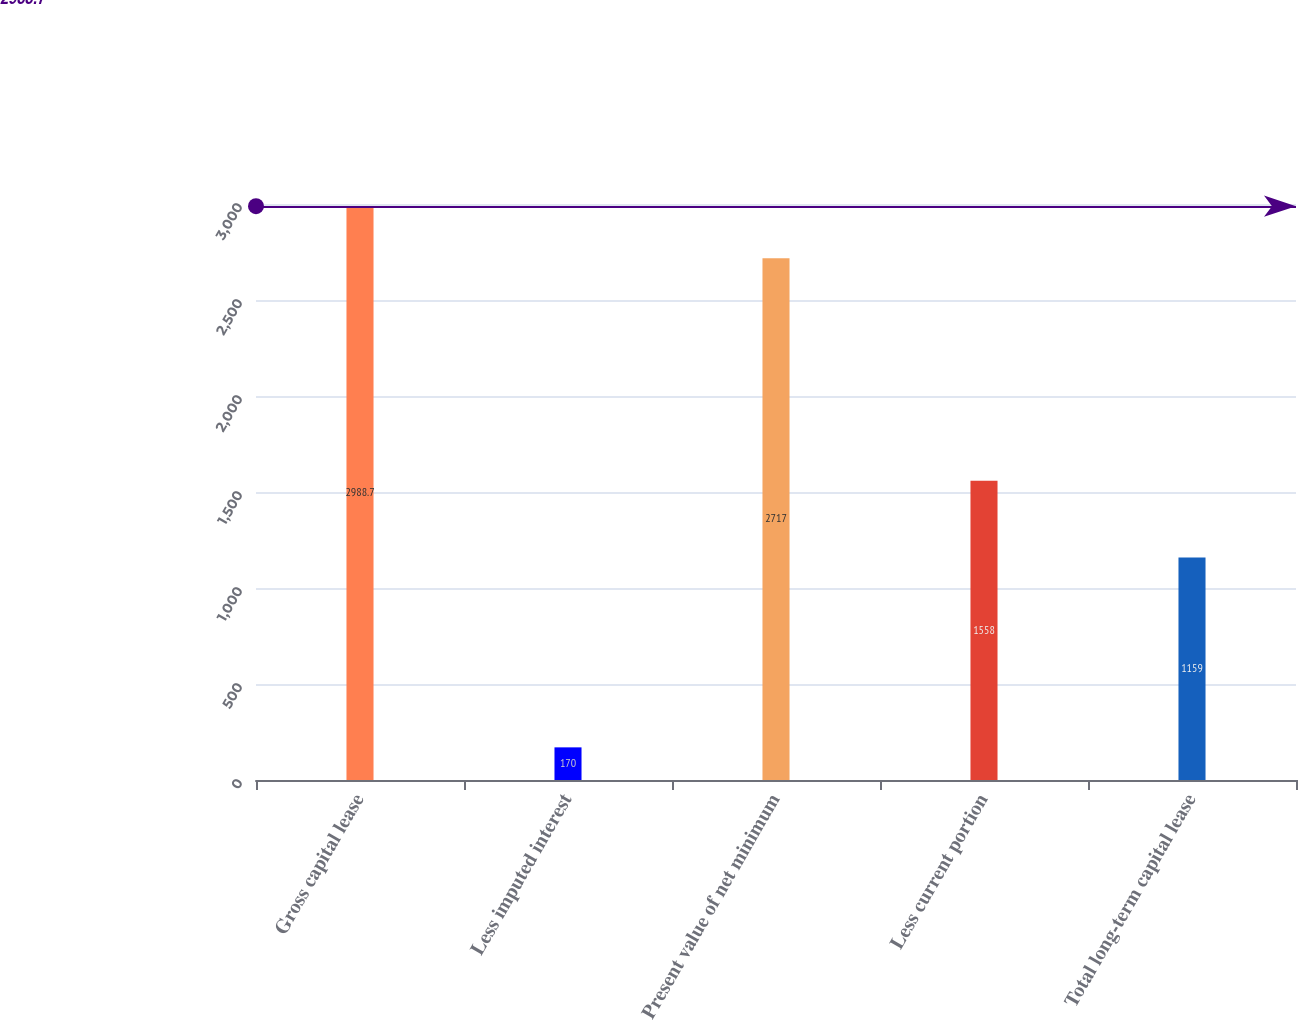Convert chart to OTSL. <chart><loc_0><loc_0><loc_500><loc_500><bar_chart><fcel>Gross capital lease<fcel>Less imputed interest<fcel>Present value of net minimum<fcel>Less current portion<fcel>Total long-term capital lease<nl><fcel>2988.7<fcel>170<fcel>2717<fcel>1558<fcel>1159<nl></chart> 